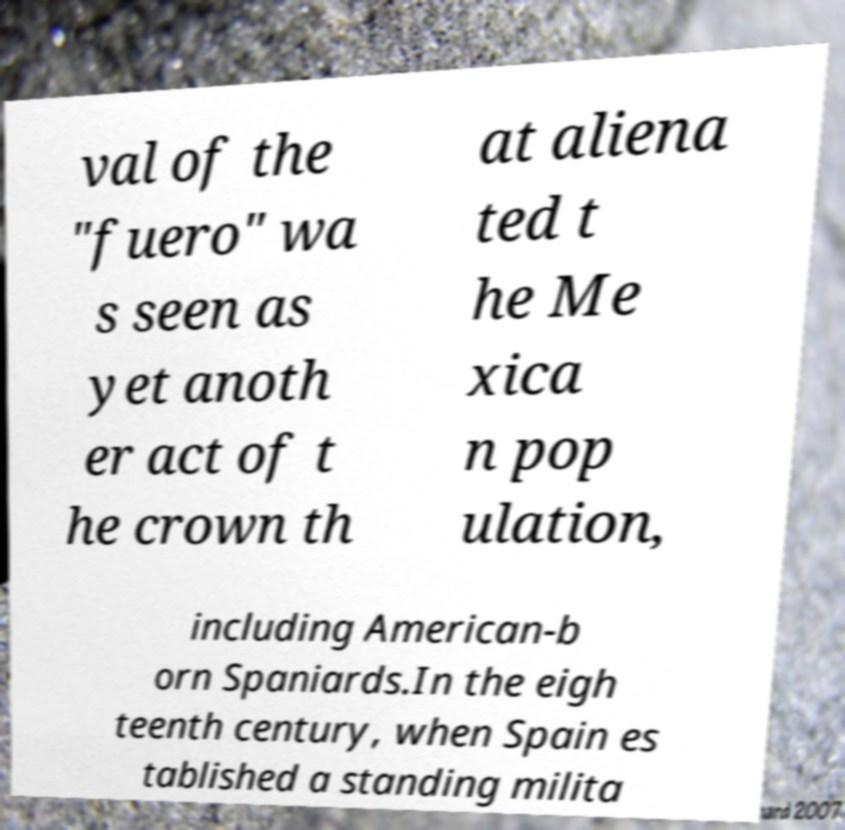Can you accurately transcribe the text from the provided image for me? val of the "fuero" wa s seen as yet anoth er act of t he crown th at aliena ted t he Me xica n pop ulation, including American-b orn Spaniards.In the eigh teenth century, when Spain es tablished a standing milita 